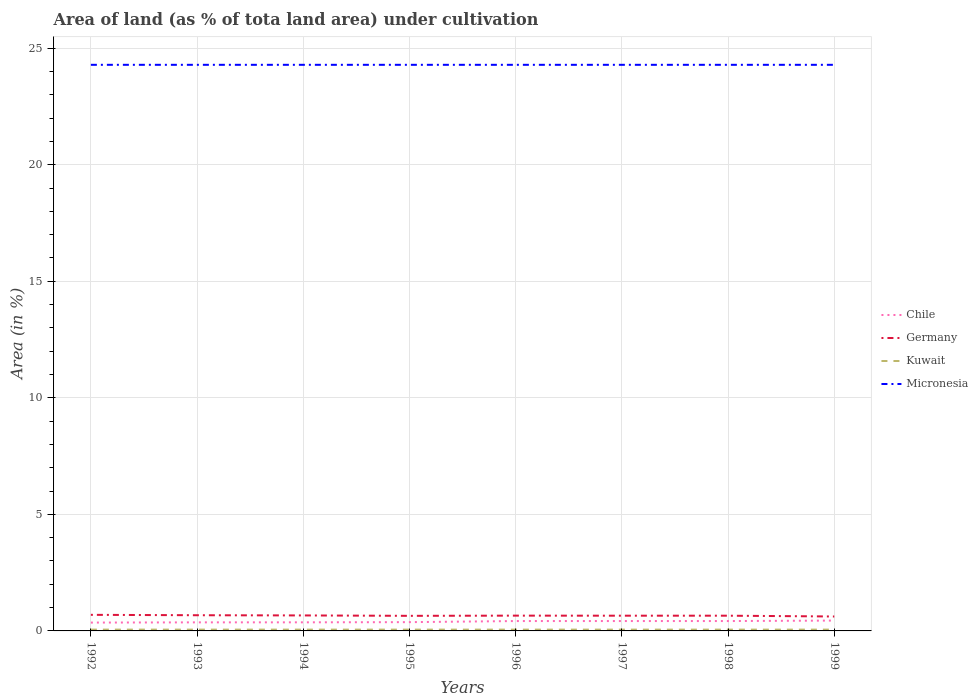How many different coloured lines are there?
Your answer should be very brief. 4. Is the number of lines equal to the number of legend labels?
Keep it short and to the point. Yes. Across all years, what is the maximum percentage of land under cultivation in Kuwait?
Give a very brief answer. 0.06. What is the total percentage of land under cultivation in Kuwait in the graph?
Provide a short and direct response. 0. What is the difference between the highest and the second highest percentage of land under cultivation in Micronesia?
Provide a short and direct response. 0. Is the percentage of land under cultivation in Micronesia strictly greater than the percentage of land under cultivation in Germany over the years?
Your response must be concise. No. How many years are there in the graph?
Give a very brief answer. 8. What is the difference between two consecutive major ticks on the Y-axis?
Make the answer very short. 5. Does the graph contain any zero values?
Keep it short and to the point. No. Where does the legend appear in the graph?
Offer a very short reply. Center right. How many legend labels are there?
Ensure brevity in your answer.  4. What is the title of the graph?
Ensure brevity in your answer.  Area of land (as % of tota land area) under cultivation. Does "Iceland" appear as one of the legend labels in the graph?
Give a very brief answer. No. What is the label or title of the X-axis?
Your response must be concise. Years. What is the label or title of the Y-axis?
Your answer should be compact. Area (in %). What is the Area (in %) of Chile in 1992?
Provide a short and direct response. 0.36. What is the Area (in %) of Germany in 1992?
Your answer should be compact. 0.69. What is the Area (in %) of Kuwait in 1992?
Ensure brevity in your answer.  0.06. What is the Area (in %) in Micronesia in 1992?
Your answer should be compact. 24.29. What is the Area (in %) of Chile in 1993?
Provide a short and direct response. 0.37. What is the Area (in %) in Germany in 1993?
Your response must be concise. 0.67. What is the Area (in %) in Kuwait in 1993?
Ensure brevity in your answer.  0.06. What is the Area (in %) in Micronesia in 1993?
Give a very brief answer. 24.29. What is the Area (in %) of Chile in 1994?
Ensure brevity in your answer.  0.37. What is the Area (in %) in Germany in 1994?
Give a very brief answer. 0.66. What is the Area (in %) in Kuwait in 1994?
Your answer should be compact. 0.06. What is the Area (in %) of Micronesia in 1994?
Offer a very short reply. 24.29. What is the Area (in %) in Chile in 1995?
Give a very brief answer. 0.38. What is the Area (in %) of Germany in 1995?
Ensure brevity in your answer.  0.65. What is the Area (in %) in Kuwait in 1995?
Give a very brief answer. 0.06. What is the Area (in %) in Micronesia in 1995?
Make the answer very short. 24.29. What is the Area (in %) in Chile in 1996?
Give a very brief answer. 0.42. What is the Area (in %) in Germany in 1996?
Give a very brief answer. 0.66. What is the Area (in %) of Kuwait in 1996?
Make the answer very short. 0.06. What is the Area (in %) of Micronesia in 1996?
Provide a succinct answer. 24.29. What is the Area (in %) of Chile in 1997?
Your answer should be compact. 0.42. What is the Area (in %) in Germany in 1997?
Ensure brevity in your answer.  0.65. What is the Area (in %) of Kuwait in 1997?
Offer a very short reply. 0.06. What is the Area (in %) of Micronesia in 1997?
Provide a succinct answer. 24.29. What is the Area (in %) in Chile in 1998?
Offer a terse response. 0.42. What is the Area (in %) in Germany in 1998?
Offer a terse response. 0.65. What is the Area (in %) of Kuwait in 1998?
Your answer should be compact. 0.06. What is the Area (in %) in Micronesia in 1998?
Your response must be concise. 24.29. What is the Area (in %) of Chile in 1999?
Make the answer very short. 0.44. What is the Area (in %) in Germany in 1999?
Keep it short and to the point. 0.62. What is the Area (in %) in Kuwait in 1999?
Give a very brief answer. 0.06. What is the Area (in %) of Micronesia in 1999?
Make the answer very short. 24.29. Across all years, what is the maximum Area (in %) of Chile?
Your answer should be compact. 0.44. Across all years, what is the maximum Area (in %) of Germany?
Your response must be concise. 0.69. Across all years, what is the maximum Area (in %) of Kuwait?
Provide a short and direct response. 0.06. Across all years, what is the maximum Area (in %) in Micronesia?
Ensure brevity in your answer.  24.29. Across all years, what is the minimum Area (in %) of Chile?
Offer a very short reply. 0.36. Across all years, what is the minimum Area (in %) in Germany?
Provide a short and direct response. 0.62. Across all years, what is the minimum Area (in %) in Kuwait?
Give a very brief answer. 0.06. Across all years, what is the minimum Area (in %) in Micronesia?
Your answer should be compact. 24.29. What is the total Area (in %) in Chile in the graph?
Your response must be concise. 3.18. What is the total Area (in %) in Germany in the graph?
Your answer should be compact. 5.26. What is the total Area (in %) in Kuwait in the graph?
Offer a very short reply. 0.45. What is the total Area (in %) in Micronesia in the graph?
Make the answer very short. 194.29. What is the difference between the Area (in %) in Chile in 1992 and that in 1993?
Provide a succinct answer. -0.01. What is the difference between the Area (in %) in Germany in 1992 and that in 1993?
Make the answer very short. 0.02. What is the difference between the Area (in %) in Micronesia in 1992 and that in 1993?
Offer a very short reply. 0. What is the difference between the Area (in %) in Chile in 1992 and that in 1994?
Give a very brief answer. -0.01. What is the difference between the Area (in %) of Germany in 1992 and that in 1994?
Your answer should be compact. 0.03. What is the difference between the Area (in %) of Kuwait in 1992 and that in 1994?
Ensure brevity in your answer.  0. What is the difference between the Area (in %) of Micronesia in 1992 and that in 1994?
Provide a succinct answer. 0. What is the difference between the Area (in %) of Chile in 1992 and that in 1995?
Keep it short and to the point. -0.02. What is the difference between the Area (in %) of Germany in 1992 and that in 1995?
Your answer should be compact. 0.04. What is the difference between the Area (in %) of Kuwait in 1992 and that in 1995?
Give a very brief answer. 0. What is the difference between the Area (in %) of Chile in 1992 and that in 1996?
Ensure brevity in your answer.  -0.07. What is the difference between the Area (in %) of Germany in 1992 and that in 1996?
Offer a very short reply. 0.03. What is the difference between the Area (in %) in Kuwait in 1992 and that in 1996?
Provide a short and direct response. 0. What is the difference between the Area (in %) in Chile in 1992 and that in 1997?
Offer a terse response. -0.07. What is the difference between the Area (in %) in Germany in 1992 and that in 1997?
Offer a terse response. 0.04. What is the difference between the Area (in %) of Chile in 1992 and that in 1998?
Your answer should be very brief. -0.07. What is the difference between the Area (in %) of Germany in 1992 and that in 1998?
Make the answer very short. 0.04. What is the difference between the Area (in %) of Kuwait in 1992 and that in 1998?
Keep it short and to the point. 0. What is the difference between the Area (in %) in Micronesia in 1992 and that in 1998?
Your answer should be compact. 0. What is the difference between the Area (in %) in Chile in 1992 and that in 1999?
Offer a very short reply. -0.09. What is the difference between the Area (in %) of Germany in 1992 and that in 1999?
Provide a succinct answer. 0.07. What is the difference between the Area (in %) of Micronesia in 1992 and that in 1999?
Give a very brief answer. 0. What is the difference between the Area (in %) in Chile in 1993 and that in 1994?
Your response must be concise. -0. What is the difference between the Area (in %) in Germany in 1993 and that in 1994?
Your answer should be compact. 0.01. What is the difference between the Area (in %) of Kuwait in 1993 and that in 1994?
Make the answer very short. 0. What is the difference between the Area (in %) of Chile in 1993 and that in 1995?
Provide a short and direct response. -0.01. What is the difference between the Area (in %) in Germany in 1993 and that in 1995?
Your answer should be very brief. 0.03. What is the difference between the Area (in %) of Chile in 1993 and that in 1996?
Keep it short and to the point. -0.06. What is the difference between the Area (in %) of Germany in 1993 and that in 1996?
Provide a short and direct response. 0.02. What is the difference between the Area (in %) in Chile in 1993 and that in 1997?
Make the answer very short. -0.06. What is the difference between the Area (in %) of Germany in 1993 and that in 1997?
Ensure brevity in your answer.  0.02. What is the difference between the Area (in %) of Chile in 1993 and that in 1998?
Keep it short and to the point. -0.06. What is the difference between the Area (in %) of Germany in 1993 and that in 1998?
Give a very brief answer. 0.02. What is the difference between the Area (in %) in Kuwait in 1993 and that in 1998?
Provide a succinct answer. 0. What is the difference between the Area (in %) in Micronesia in 1993 and that in 1998?
Provide a short and direct response. 0. What is the difference between the Area (in %) of Chile in 1993 and that in 1999?
Ensure brevity in your answer.  -0.08. What is the difference between the Area (in %) of Germany in 1993 and that in 1999?
Your answer should be very brief. 0.05. What is the difference between the Area (in %) of Micronesia in 1993 and that in 1999?
Your response must be concise. 0. What is the difference between the Area (in %) of Chile in 1994 and that in 1995?
Your answer should be compact. -0.01. What is the difference between the Area (in %) of Germany in 1994 and that in 1995?
Offer a very short reply. 0.02. What is the difference between the Area (in %) of Kuwait in 1994 and that in 1995?
Keep it short and to the point. 0. What is the difference between the Area (in %) in Micronesia in 1994 and that in 1995?
Offer a terse response. 0. What is the difference between the Area (in %) in Chile in 1994 and that in 1996?
Give a very brief answer. -0.06. What is the difference between the Area (in %) of Germany in 1994 and that in 1996?
Ensure brevity in your answer.  0.01. What is the difference between the Area (in %) of Kuwait in 1994 and that in 1996?
Offer a terse response. 0. What is the difference between the Area (in %) in Chile in 1994 and that in 1997?
Provide a short and direct response. -0.06. What is the difference between the Area (in %) in Germany in 1994 and that in 1997?
Provide a short and direct response. 0.01. What is the difference between the Area (in %) in Kuwait in 1994 and that in 1997?
Offer a terse response. 0. What is the difference between the Area (in %) of Chile in 1994 and that in 1998?
Ensure brevity in your answer.  -0.06. What is the difference between the Area (in %) of Germany in 1994 and that in 1998?
Give a very brief answer. 0.01. What is the difference between the Area (in %) of Micronesia in 1994 and that in 1998?
Make the answer very short. 0. What is the difference between the Area (in %) in Chile in 1994 and that in 1999?
Give a very brief answer. -0.08. What is the difference between the Area (in %) of Germany in 1994 and that in 1999?
Provide a short and direct response. 0.05. What is the difference between the Area (in %) in Micronesia in 1994 and that in 1999?
Your answer should be compact. 0. What is the difference between the Area (in %) in Chile in 1995 and that in 1996?
Provide a short and direct response. -0.05. What is the difference between the Area (in %) in Germany in 1995 and that in 1996?
Provide a short and direct response. -0.01. What is the difference between the Area (in %) of Micronesia in 1995 and that in 1996?
Offer a very short reply. 0. What is the difference between the Area (in %) in Chile in 1995 and that in 1997?
Offer a very short reply. -0.05. What is the difference between the Area (in %) of Germany in 1995 and that in 1997?
Ensure brevity in your answer.  -0.01. What is the difference between the Area (in %) of Micronesia in 1995 and that in 1997?
Offer a terse response. 0. What is the difference between the Area (in %) of Chile in 1995 and that in 1998?
Provide a short and direct response. -0.05. What is the difference between the Area (in %) of Germany in 1995 and that in 1998?
Provide a succinct answer. -0.01. What is the difference between the Area (in %) of Kuwait in 1995 and that in 1998?
Offer a terse response. 0. What is the difference between the Area (in %) of Micronesia in 1995 and that in 1998?
Offer a terse response. 0. What is the difference between the Area (in %) in Chile in 1995 and that in 1999?
Your answer should be compact. -0.07. What is the difference between the Area (in %) in Germany in 1995 and that in 1999?
Keep it short and to the point. 0.03. What is the difference between the Area (in %) in Micronesia in 1995 and that in 1999?
Your response must be concise. 0. What is the difference between the Area (in %) in Chile in 1996 and that in 1997?
Provide a short and direct response. 0. What is the difference between the Area (in %) in Germany in 1996 and that in 1997?
Give a very brief answer. 0. What is the difference between the Area (in %) in Germany in 1996 and that in 1998?
Your answer should be compact. 0. What is the difference between the Area (in %) in Chile in 1996 and that in 1999?
Offer a terse response. -0.02. What is the difference between the Area (in %) of Germany in 1996 and that in 1999?
Keep it short and to the point. 0.04. What is the difference between the Area (in %) of Kuwait in 1996 and that in 1999?
Provide a succinct answer. 0. What is the difference between the Area (in %) of Germany in 1997 and that in 1998?
Provide a succinct answer. -0. What is the difference between the Area (in %) in Chile in 1997 and that in 1999?
Give a very brief answer. -0.02. What is the difference between the Area (in %) in Germany in 1997 and that in 1999?
Provide a succinct answer. 0.03. What is the difference between the Area (in %) in Kuwait in 1997 and that in 1999?
Keep it short and to the point. 0. What is the difference between the Area (in %) in Chile in 1998 and that in 1999?
Provide a succinct answer. -0.02. What is the difference between the Area (in %) of Germany in 1998 and that in 1999?
Make the answer very short. 0.03. What is the difference between the Area (in %) in Micronesia in 1998 and that in 1999?
Your answer should be compact. 0. What is the difference between the Area (in %) of Chile in 1992 and the Area (in %) of Germany in 1993?
Offer a very short reply. -0.32. What is the difference between the Area (in %) in Chile in 1992 and the Area (in %) in Kuwait in 1993?
Offer a terse response. 0.3. What is the difference between the Area (in %) in Chile in 1992 and the Area (in %) in Micronesia in 1993?
Keep it short and to the point. -23.93. What is the difference between the Area (in %) of Germany in 1992 and the Area (in %) of Kuwait in 1993?
Your response must be concise. 0.63. What is the difference between the Area (in %) in Germany in 1992 and the Area (in %) in Micronesia in 1993?
Keep it short and to the point. -23.6. What is the difference between the Area (in %) of Kuwait in 1992 and the Area (in %) of Micronesia in 1993?
Offer a terse response. -24.23. What is the difference between the Area (in %) of Chile in 1992 and the Area (in %) of Germany in 1994?
Offer a very short reply. -0.31. What is the difference between the Area (in %) of Chile in 1992 and the Area (in %) of Kuwait in 1994?
Ensure brevity in your answer.  0.3. What is the difference between the Area (in %) of Chile in 1992 and the Area (in %) of Micronesia in 1994?
Your response must be concise. -23.93. What is the difference between the Area (in %) of Germany in 1992 and the Area (in %) of Kuwait in 1994?
Your answer should be very brief. 0.63. What is the difference between the Area (in %) in Germany in 1992 and the Area (in %) in Micronesia in 1994?
Your answer should be very brief. -23.6. What is the difference between the Area (in %) in Kuwait in 1992 and the Area (in %) in Micronesia in 1994?
Keep it short and to the point. -24.23. What is the difference between the Area (in %) of Chile in 1992 and the Area (in %) of Germany in 1995?
Ensure brevity in your answer.  -0.29. What is the difference between the Area (in %) of Chile in 1992 and the Area (in %) of Kuwait in 1995?
Your answer should be compact. 0.3. What is the difference between the Area (in %) in Chile in 1992 and the Area (in %) in Micronesia in 1995?
Give a very brief answer. -23.93. What is the difference between the Area (in %) of Germany in 1992 and the Area (in %) of Kuwait in 1995?
Make the answer very short. 0.63. What is the difference between the Area (in %) of Germany in 1992 and the Area (in %) of Micronesia in 1995?
Keep it short and to the point. -23.6. What is the difference between the Area (in %) in Kuwait in 1992 and the Area (in %) in Micronesia in 1995?
Keep it short and to the point. -24.23. What is the difference between the Area (in %) of Chile in 1992 and the Area (in %) of Germany in 1996?
Provide a short and direct response. -0.3. What is the difference between the Area (in %) of Chile in 1992 and the Area (in %) of Kuwait in 1996?
Your answer should be very brief. 0.3. What is the difference between the Area (in %) of Chile in 1992 and the Area (in %) of Micronesia in 1996?
Your answer should be compact. -23.93. What is the difference between the Area (in %) in Germany in 1992 and the Area (in %) in Kuwait in 1996?
Give a very brief answer. 0.63. What is the difference between the Area (in %) in Germany in 1992 and the Area (in %) in Micronesia in 1996?
Give a very brief answer. -23.6. What is the difference between the Area (in %) in Kuwait in 1992 and the Area (in %) in Micronesia in 1996?
Your answer should be very brief. -24.23. What is the difference between the Area (in %) of Chile in 1992 and the Area (in %) of Germany in 1997?
Your answer should be compact. -0.3. What is the difference between the Area (in %) in Chile in 1992 and the Area (in %) in Kuwait in 1997?
Your answer should be compact. 0.3. What is the difference between the Area (in %) in Chile in 1992 and the Area (in %) in Micronesia in 1997?
Your response must be concise. -23.93. What is the difference between the Area (in %) in Germany in 1992 and the Area (in %) in Kuwait in 1997?
Your response must be concise. 0.63. What is the difference between the Area (in %) in Germany in 1992 and the Area (in %) in Micronesia in 1997?
Ensure brevity in your answer.  -23.6. What is the difference between the Area (in %) in Kuwait in 1992 and the Area (in %) in Micronesia in 1997?
Offer a very short reply. -24.23. What is the difference between the Area (in %) of Chile in 1992 and the Area (in %) of Germany in 1998?
Provide a succinct answer. -0.3. What is the difference between the Area (in %) of Chile in 1992 and the Area (in %) of Kuwait in 1998?
Your answer should be compact. 0.3. What is the difference between the Area (in %) of Chile in 1992 and the Area (in %) of Micronesia in 1998?
Provide a succinct answer. -23.93. What is the difference between the Area (in %) of Germany in 1992 and the Area (in %) of Kuwait in 1998?
Offer a terse response. 0.63. What is the difference between the Area (in %) in Germany in 1992 and the Area (in %) in Micronesia in 1998?
Offer a very short reply. -23.6. What is the difference between the Area (in %) of Kuwait in 1992 and the Area (in %) of Micronesia in 1998?
Provide a short and direct response. -24.23. What is the difference between the Area (in %) of Chile in 1992 and the Area (in %) of Germany in 1999?
Offer a terse response. -0.26. What is the difference between the Area (in %) in Chile in 1992 and the Area (in %) in Kuwait in 1999?
Provide a short and direct response. 0.3. What is the difference between the Area (in %) of Chile in 1992 and the Area (in %) of Micronesia in 1999?
Give a very brief answer. -23.93. What is the difference between the Area (in %) of Germany in 1992 and the Area (in %) of Kuwait in 1999?
Offer a very short reply. 0.63. What is the difference between the Area (in %) in Germany in 1992 and the Area (in %) in Micronesia in 1999?
Your answer should be very brief. -23.6. What is the difference between the Area (in %) in Kuwait in 1992 and the Area (in %) in Micronesia in 1999?
Your answer should be compact. -24.23. What is the difference between the Area (in %) of Chile in 1993 and the Area (in %) of Germany in 1994?
Your answer should be compact. -0.3. What is the difference between the Area (in %) of Chile in 1993 and the Area (in %) of Kuwait in 1994?
Offer a very short reply. 0.31. What is the difference between the Area (in %) in Chile in 1993 and the Area (in %) in Micronesia in 1994?
Ensure brevity in your answer.  -23.92. What is the difference between the Area (in %) of Germany in 1993 and the Area (in %) of Kuwait in 1994?
Your response must be concise. 0.62. What is the difference between the Area (in %) in Germany in 1993 and the Area (in %) in Micronesia in 1994?
Offer a terse response. -23.61. What is the difference between the Area (in %) of Kuwait in 1993 and the Area (in %) of Micronesia in 1994?
Your answer should be very brief. -24.23. What is the difference between the Area (in %) of Chile in 1993 and the Area (in %) of Germany in 1995?
Offer a very short reply. -0.28. What is the difference between the Area (in %) in Chile in 1993 and the Area (in %) in Kuwait in 1995?
Your answer should be compact. 0.31. What is the difference between the Area (in %) of Chile in 1993 and the Area (in %) of Micronesia in 1995?
Ensure brevity in your answer.  -23.92. What is the difference between the Area (in %) of Germany in 1993 and the Area (in %) of Kuwait in 1995?
Keep it short and to the point. 0.62. What is the difference between the Area (in %) of Germany in 1993 and the Area (in %) of Micronesia in 1995?
Keep it short and to the point. -23.61. What is the difference between the Area (in %) of Kuwait in 1993 and the Area (in %) of Micronesia in 1995?
Provide a succinct answer. -24.23. What is the difference between the Area (in %) in Chile in 1993 and the Area (in %) in Germany in 1996?
Provide a short and direct response. -0.29. What is the difference between the Area (in %) in Chile in 1993 and the Area (in %) in Kuwait in 1996?
Your response must be concise. 0.31. What is the difference between the Area (in %) in Chile in 1993 and the Area (in %) in Micronesia in 1996?
Give a very brief answer. -23.92. What is the difference between the Area (in %) in Germany in 1993 and the Area (in %) in Kuwait in 1996?
Your answer should be compact. 0.62. What is the difference between the Area (in %) of Germany in 1993 and the Area (in %) of Micronesia in 1996?
Your answer should be compact. -23.61. What is the difference between the Area (in %) of Kuwait in 1993 and the Area (in %) of Micronesia in 1996?
Provide a short and direct response. -24.23. What is the difference between the Area (in %) of Chile in 1993 and the Area (in %) of Germany in 1997?
Make the answer very short. -0.29. What is the difference between the Area (in %) in Chile in 1993 and the Area (in %) in Kuwait in 1997?
Make the answer very short. 0.31. What is the difference between the Area (in %) of Chile in 1993 and the Area (in %) of Micronesia in 1997?
Make the answer very short. -23.92. What is the difference between the Area (in %) of Germany in 1993 and the Area (in %) of Kuwait in 1997?
Your answer should be compact. 0.62. What is the difference between the Area (in %) of Germany in 1993 and the Area (in %) of Micronesia in 1997?
Your answer should be very brief. -23.61. What is the difference between the Area (in %) in Kuwait in 1993 and the Area (in %) in Micronesia in 1997?
Provide a succinct answer. -24.23. What is the difference between the Area (in %) of Chile in 1993 and the Area (in %) of Germany in 1998?
Keep it short and to the point. -0.29. What is the difference between the Area (in %) in Chile in 1993 and the Area (in %) in Kuwait in 1998?
Provide a succinct answer. 0.31. What is the difference between the Area (in %) of Chile in 1993 and the Area (in %) of Micronesia in 1998?
Keep it short and to the point. -23.92. What is the difference between the Area (in %) in Germany in 1993 and the Area (in %) in Kuwait in 1998?
Provide a succinct answer. 0.62. What is the difference between the Area (in %) of Germany in 1993 and the Area (in %) of Micronesia in 1998?
Keep it short and to the point. -23.61. What is the difference between the Area (in %) of Kuwait in 1993 and the Area (in %) of Micronesia in 1998?
Offer a terse response. -24.23. What is the difference between the Area (in %) in Chile in 1993 and the Area (in %) in Germany in 1999?
Provide a succinct answer. -0.25. What is the difference between the Area (in %) in Chile in 1993 and the Area (in %) in Kuwait in 1999?
Provide a short and direct response. 0.31. What is the difference between the Area (in %) of Chile in 1993 and the Area (in %) of Micronesia in 1999?
Give a very brief answer. -23.92. What is the difference between the Area (in %) in Germany in 1993 and the Area (in %) in Kuwait in 1999?
Your response must be concise. 0.62. What is the difference between the Area (in %) of Germany in 1993 and the Area (in %) of Micronesia in 1999?
Ensure brevity in your answer.  -23.61. What is the difference between the Area (in %) of Kuwait in 1993 and the Area (in %) of Micronesia in 1999?
Offer a terse response. -24.23. What is the difference between the Area (in %) of Chile in 1994 and the Area (in %) of Germany in 1995?
Ensure brevity in your answer.  -0.28. What is the difference between the Area (in %) in Chile in 1994 and the Area (in %) in Kuwait in 1995?
Make the answer very short. 0.31. What is the difference between the Area (in %) in Chile in 1994 and the Area (in %) in Micronesia in 1995?
Provide a succinct answer. -23.92. What is the difference between the Area (in %) of Germany in 1994 and the Area (in %) of Kuwait in 1995?
Your answer should be very brief. 0.61. What is the difference between the Area (in %) of Germany in 1994 and the Area (in %) of Micronesia in 1995?
Make the answer very short. -23.62. What is the difference between the Area (in %) in Kuwait in 1994 and the Area (in %) in Micronesia in 1995?
Offer a terse response. -24.23. What is the difference between the Area (in %) in Chile in 1994 and the Area (in %) in Germany in 1996?
Provide a short and direct response. -0.29. What is the difference between the Area (in %) of Chile in 1994 and the Area (in %) of Kuwait in 1996?
Your answer should be compact. 0.31. What is the difference between the Area (in %) in Chile in 1994 and the Area (in %) in Micronesia in 1996?
Offer a terse response. -23.92. What is the difference between the Area (in %) in Germany in 1994 and the Area (in %) in Kuwait in 1996?
Your answer should be very brief. 0.61. What is the difference between the Area (in %) in Germany in 1994 and the Area (in %) in Micronesia in 1996?
Keep it short and to the point. -23.62. What is the difference between the Area (in %) of Kuwait in 1994 and the Area (in %) of Micronesia in 1996?
Make the answer very short. -24.23. What is the difference between the Area (in %) in Chile in 1994 and the Area (in %) in Germany in 1997?
Your response must be concise. -0.28. What is the difference between the Area (in %) in Chile in 1994 and the Area (in %) in Kuwait in 1997?
Your answer should be very brief. 0.31. What is the difference between the Area (in %) of Chile in 1994 and the Area (in %) of Micronesia in 1997?
Offer a terse response. -23.92. What is the difference between the Area (in %) of Germany in 1994 and the Area (in %) of Kuwait in 1997?
Your response must be concise. 0.61. What is the difference between the Area (in %) in Germany in 1994 and the Area (in %) in Micronesia in 1997?
Provide a short and direct response. -23.62. What is the difference between the Area (in %) in Kuwait in 1994 and the Area (in %) in Micronesia in 1997?
Provide a short and direct response. -24.23. What is the difference between the Area (in %) of Chile in 1994 and the Area (in %) of Germany in 1998?
Offer a terse response. -0.28. What is the difference between the Area (in %) in Chile in 1994 and the Area (in %) in Kuwait in 1998?
Keep it short and to the point. 0.31. What is the difference between the Area (in %) in Chile in 1994 and the Area (in %) in Micronesia in 1998?
Offer a terse response. -23.92. What is the difference between the Area (in %) in Germany in 1994 and the Area (in %) in Kuwait in 1998?
Make the answer very short. 0.61. What is the difference between the Area (in %) of Germany in 1994 and the Area (in %) of Micronesia in 1998?
Keep it short and to the point. -23.62. What is the difference between the Area (in %) of Kuwait in 1994 and the Area (in %) of Micronesia in 1998?
Your response must be concise. -24.23. What is the difference between the Area (in %) of Chile in 1994 and the Area (in %) of Germany in 1999?
Your answer should be compact. -0.25. What is the difference between the Area (in %) of Chile in 1994 and the Area (in %) of Kuwait in 1999?
Your answer should be compact. 0.31. What is the difference between the Area (in %) of Chile in 1994 and the Area (in %) of Micronesia in 1999?
Provide a short and direct response. -23.92. What is the difference between the Area (in %) of Germany in 1994 and the Area (in %) of Kuwait in 1999?
Provide a succinct answer. 0.61. What is the difference between the Area (in %) of Germany in 1994 and the Area (in %) of Micronesia in 1999?
Your answer should be compact. -23.62. What is the difference between the Area (in %) of Kuwait in 1994 and the Area (in %) of Micronesia in 1999?
Your answer should be compact. -24.23. What is the difference between the Area (in %) of Chile in 1995 and the Area (in %) of Germany in 1996?
Your answer should be very brief. -0.28. What is the difference between the Area (in %) of Chile in 1995 and the Area (in %) of Kuwait in 1996?
Keep it short and to the point. 0.32. What is the difference between the Area (in %) of Chile in 1995 and the Area (in %) of Micronesia in 1996?
Keep it short and to the point. -23.91. What is the difference between the Area (in %) of Germany in 1995 and the Area (in %) of Kuwait in 1996?
Your answer should be compact. 0.59. What is the difference between the Area (in %) in Germany in 1995 and the Area (in %) in Micronesia in 1996?
Provide a succinct answer. -23.64. What is the difference between the Area (in %) in Kuwait in 1995 and the Area (in %) in Micronesia in 1996?
Provide a succinct answer. -24.23. What is the difference between the Area (in %) of Chile in 1995 and the Area (in %) of Germany in 1997?
Your answer should be compact. -0.28. What is the difference between the Area (in %) of Chile in 1995 and the Area (in %) of Kuwait in 1997?
Your response must be concise. 0.32. What is the difference between the Area (in %) of Chile in 1995 and the Area (in %) of Micronesia in 1997?
Offer a very short reply. -23.91. What is the difference between the Area (in %) of Germany in 1995 and the Area (in %) of Kuwait in 1997?
Offer a very short reply. 0.59. What is the difference between the Area (in %) of Germany in 1995 and the Area (in %) of Micronesia in 1997?
Your response must be concise. -23.64. What is the difference between the Area (in %) of Kuwait in 1995 and the Area (in %) of Micronesia in 1997?
Offer a very short reply. -24.23. What is the difference between the Area (in %) of Chile in 1995 and the Area (in %) of Germany in 1998?
Your answer should be very brief. -0.28. What is the difference between the Area (in %) of Chile in 1995 and the Area (in %) of Kuwait in 1998?
Your answer should be compact. 0.32. What is the difference between the Area (in %) of Chile in 1995 and the Area (in %) of Micronesia in 1998?
Offer a very short reply. -23.91. What is the difference between the Area (in %) of Germany in 1995 and the Area (in %) of Kuwait in 1998?
Your response must be concise. 0.59. What is the difference between the Area (in %) of Germany in 1995 and the Area (in %) of Micronesia in 1998?
Keep it short and to the point. -23.64. What is the difference between the Area (in %) in Kuwait in 1995 and the Area (in %) in Micronesia in 1998?
Make the answer very short. -24.23. What is the difference between the Area (in %) in Chile in 1995 and the Area (in %) in Germany in 1999?
Provide a succinct answer. -0.24. What is the difference between the Area (in %) in Chile in 1995 and the Area (in %) in Kuwait in 1999?
Offer a terse response. 0.32. What is the difference between the Area (in %) of Chile in 1995 and the Area (in %) of Micronesia in 1999?
Your response must be concise. -23.91. What is the difference between the Area (in %) in Germany in 1995 and the Area (in %) in Kuwait in 1999?
Ensure brevity in your answer.  0.59. What is the difference between the Area (in %) in Germany in 1995 and the Area (in %) in Micronesia in 1999?
Provide a short and direct response. -23.64. What is the difference between the Area (in %) in Kuwait in 1995 and the Area (in %) in Micronesia in 1999?
Offer a terse response. -24.23. What is the difference between the Area (in %) in Chile in 1996 and the Area (in %) in Germany in 1997?
Provide a short and direct response. -0.23. What is the difference between the Area (in %) of Chile in 1996 and the Area (in %) of Kuwait in 1997?
Your response must be concise. 0.37. What is the difference between the Area (in %) of Chile in 1996 and the Area (in %) of Micronesia in 1997?
Offer a terse response. -23.86. What is the difference between the Area (in %) of Germany in 1996 and the Area (in %) of Kuwait in 1997?
Keep it short and to the point. 0.6. What is the difference between the Area (in %) in Germany in 1996 and the Area (in %) in Micronesia in 1997?
Provide a succinct answer. -23.63. What is the difference between the Area (in %) in Kuwait in 1996 and the Area (in %) in Micronesia in 1997?
Offer a terse response. -24.23. What is the difference between the Area (in %) in Chile in 1996 and the Area (in %) in Germany in 1998?
Keep it short and to the point. -0.23. What is the difference between the Area (in %) of Chile in 1996 and the Area (in %) of Kuwait in 1998?
Your answer should be compact. 0.37. What is the difference between the Area (in %) of Chile in 1996 and the Area (in %) of Micronesia in 1998?
Give a very brief answer. -23.86. What is the difference between the Area (in %) of Germany in 1996 and the Area (in %) of Kuwait in 1998?
Your answer should be very brief. 0.6. What is the difference between the Area (in %) of Germany in 1996 and the Area (in %) of Micronesia in 1998?
Provide a succinct answer. -23.63. What is the difference between the Area (in %) in Kuwait in 1996 and the Area (in %) in Micronesia in 1998?
Your answer should be compact. -24.23. What is the difference between the Area (in %) of Chile in 1996 and the Area (in %) of Germany in 1999?
Keep it short and to the point. -0.2. What is the difference between the Area (in %) in Chile in 1996 and the Area (in %) in Kuwait in 1999?
Keep it short and to the point. 0.37. What is the difference between the Area (in %) in Chile in 1996 and the Area (in %) in Micronesia in 1999?
Ensure brevity in your answer.  -23.86. What is the difference between the Area (in %) in Germany in 1996 and the Area (in %) in Kuwait in 1999?
Your answer should be very brief. 0.6. What is the difference between the Area (in %) in Germany in 1996 and the Area (in %) in Micronesia in 1999?
Offer a terse response. -23.63. What is the difference between the Area (in %) of Kuwait in 1996 and the Area (in %) of Micronesia in 1999?
Your answer should be compact. -24.23. What is the difference between the Area (in %) in Chile in 1997 and the Area (in %) in Germany in 1998?
Provide a short and direct response. -0.23. What is the difference between the Area (in %) in Chile in 1997 and the Area (in %) in Kuwait in 1998?
Give a very brief answer. 0.37. What is the difference between the Area (in %) in Chile in 1997 and the Area (in %) in Micronesia in 1998?
Your answer should be compact. -23.86. What is the difference between the Area (in %) of Germany in 1997 and the Area (in %) of Kuwait in 1998?
Offer a terse response. 0.6. What is the difference between the Area (in %) in Germany in 1997 and the Area (in %) in Micronesia in 1998?
Offer a very short reply. -23.63. What is the difference between the Area (in %) in Kuwait in 1997 and the Area (in %) in Micronesia in 1998?
Your answer should be compact. -24.23. What is the difference between the Area (in %) of Chile in 1997 and the Area (in %) of Germany in 1999?
Your response must be concise. -0.2. What is the difference between the Area (in %) in Chile in 1997 and the Area (in %) in Kuwait in 1999?
Your response must be concise. 0.37. What is the difference between the Area (in %) in Chile in 1997 and the Area (in %) in Micronesia in 1999?
Offer a very short reply. -23.86. What is the difference between the Area (in %) of Germany in 1997 and the Area (in %) of Kuwait in 1999?
Your answer should be very brief. 0.6. What is the difference between the Area (in %) of Germany in 1997 and the Area (in %) of Micronesia in 1999?
Give a very brief answer. -23.63. What is the difference between the Area (in %) of Kuwait in 1997 and the Area (in %) of Micronesia in 1999?
Provide a succinct answer. -24.23. What is the difference between the Area (in %) of Chile in 1998 and the Area (in %) of Germany in 1999?
Offer a terse response. -0.2. What is the difference between the Area (in %) of Chile in 1998 and the Area (in %) of Kuwait in 1999?
Make the answer very short. 0.37. What is the difference between the Area (in %) in Chile in 1998 and the Area (in %) in Micronesia in 1999?
Offer a terse response. -23.86. What is the difference between the Area (in %) of Germany in 1998 and the Area (in %) of Kuwait in 1999?
Keep it short and to the point. 0.6. What is the difference between the Area (in %) in Germany in 1998 and the Area (in %) in Micronesia in 1999?
Give a very brief answer. -23.63. What is the difference between the Area (in %) in Kuwait in 1998 and the Area (in %) in Micronesia in 1999?
Ensure brevity in your answer.  -24.23. What is the average Area (in %) in Chile per year?
Ensure brevity in your answer.  0.4. What is the average Area (in %) in Germany per year?
Your answer should be very brief. 0.66. What is the average Area (in %) of Kuwait per year?
Provide a short and direct response. 0.06. What is the average Area (in %) in Micronesia per year?
Ensure brevity in your answer.  24.29. In the year 1992, what is the difference between the Area (in %) of Chile and Area (in %) of Germany?
Your answer should be very brief. -0.33. In the year 1992, what is the difference between the Area (in %) in Chile and Area (in %) in Kuwait?
Make the answer very short. 0.3. In the year 1992, what is the difference between the Area (in %) of Chile and Area (in %) of Micronesia?
Offer a very short reply. -23.93. In the year 1992, what is the difference between the Area (in %) in Germany and Area (in %) in Kuwait?
Offer a terse response. 0.63. In the year 1992, what is the difference between the Area (in %) of Germany and Area (in %) of Micronesia?
Provide a succinct answer. -23.6. In the year 1992, what is the difference between the Area (in %) in Kuwait and Area (in %) in Micronesia?
Your response must be concise. -24.23. In the year 1993, what is the difference between the Area (in %) in Chile and Area (in %) in Germany?
Make the answer very short. -0.31. In the year 1993, what is the difference between the Area (in %) of Chile and Area (in %) of Kuwait?
Your response must be concise. 0.31. In the year 1993, what is the difference between the Area (in %) in Chile and Area (in %) in Micronesia?
Your response must be concise. -23.92. In the year 1993, what is the difference between the Area (in %) of Germany and Area (in %) of Kuwait?
Your answer should be compact. 0.62. In the year 1993, what is the difference between the Area (in %) in Germany and Area (in %) in Micronesia?
Offer a terse response. -23.61. In the year 1993, what is the difference between the Area (in %) of Kuwait and Area (in %) of Micronesia?
Give a very brief answer. -24.23. In the year 1994, what is the difference between the Area (in %) in Chile and Area (in %) in Germany?
Give a very brief answer. -0.3. In the year 1994, what is the difference between the Area (in %) of Chile and Area (in %) of Kuwait?
Make the answer very short. 0.31. In the year 1994, what is the difference between the Area (in %) of Chile and Area (in %) of Micronesia?
Keep it short and to the point. -23.92. In the year 1994, what is the difference between the Area (in %) of Germany and Area (in %) of Kuwait?
Keep it short and to the point. 0.61. In the year 1994, what is the difference between the Area (in %) of Germany and Area (in %) of Micronesia?
Your answer should be very brief. -23.62. In the year 1994, what is the difference between the Area (in %) in Kuwait and Area (in %) in Micronesia?
Offer a terse response. -24.23. In the year 1995, what is the difference between the Area (in %) of Chile and Area (in %) of Germany?
Your response must be concise. -0.27. In the year 1995, what is the difference between the Area (in %) in Chile and Area (in %) in Kuwait?
Ensure brevity in your answer.  0.32. In the year 1995, what is the difference between the Area (in %) of Chile and Area (in %) of Micronesia?
Give a very brief answer. -23.91. In the year 1995, what is the difference between the Area (in %) of Germany and Area (in %) of Kuwait?
Keep it short and to the point. 0.59. In the year 1995, what is the difference between the Area (in %) of Germany and Area (in %) of Micronesia?
Offer a terse response. -23.64. In the year 1995, what is the difference between the Area (in %) in Kuwait and Area (in %) in Micronesia?
Your response must be concise. -24.23. In the year 1996, what is the difference between the Area (in %) in Chile and Area (in %) in Germany?
Your response must be concise. -0.23. In the year 1996, what is the difference between the Area (in %) of Chile and Area (in %) of Kuwait?
Provide a short and direct response. 0.37. In the year 1996, what is the difference between the Area (in %) of Chile and Area (in %) of Micronesia?
Provide a short and direct response. -23.86. In the year 1996, what is the difference between the Area (in %) of Germany and Area (in %) of Kuwait?
Provide a short and direct response. 0.6. In the year 1996, what is the difference between the Area (in %) in Germany and Area (in %) in Micronesia?
Make the answer very short. -23.63. In the year 1996, what is the difference between the Area (in %) of Kuwait and Area (in %) of Micronesia?
Your response must be concise. -24.23. In the year 1997, what is the difference between the Area (in %) in Chile and Area (in %) in Germany?
Provide a succinct answer. -0.23. In the year 1997, what is the difference between the Area (in %) in Chile and Area (in %) in Kuwait?
Provide a short and direct response. 0.37. In the year 1997, what is the difference between the Area (in %) of Chile and Area (in %) of Micronesia?
Ensure brevity in your answer.  -23.86. In the year 1997, what is the difference between the Area (in %) in Germany and Area (in %) in Kuwait?
Your answer should be compact. 0.6. In the year 1997, what is the difference between the Area (in %) of Germany and Area (in %) of Micronesia?
Offer a terse response. -23.63. In the year 1997, what is the difference between the Area (in %) of Kuwait and Area (in %) of Micronesia?
Your answer should be very brief. -24.23. In the year 1998, what is the difference between the Area (in %) in Chile and Area (in %) in Germany?
Offer a very short reply. -0.23. In the year 1998, what is the difference between the Area (in %) of Chile and Area (in %) of Kuwait?
Offer a terse response. 0.37. In the year 1998, what is the difference between the Area (in %) in Chile and Area (in %) in Micronesia?
Provide a short and direct response. -23.86. In the year 1998, what is the difference between the Area (in %) of Germany and Area (in %) of Kuwait?
Offer a very short reply. 0.6. In the year 1998, what is the difference between the Area (in %) of Germany and Area (in %) of Micronesia?
Your answer should be compact. -23.63. In the year 1998, what is the difference between the Area (in %) of Kuwait and Area (in %) of Micronesia?
Keep it short and to the point. -24.23. In the year 1999, what is the difference between the Area (in %) in Chile and Area (in %) in Germany?
Your answer should be compact. -0.18. In the year 1999, what is the difference between the Area (in %) in Chile and Area (in %) in Kuwait?
Provide a succinct answer. 0.39. In the year 1999, what is the difference between the Area (in %) of Chile and Area (in %) of Micronesia?
Give a very brief answer. -23.84. In the year 1999, what is the difference between the Area (in %) in Germany and Area (in %) in Kuwait?
Offer a terse response. 0.56. In the year 1999, what is the difference between the Area (in %) of Germany and Area (in %) of Micronesia?
Provide a short and direct response. -23.67. In the year 1999, what is the difference between the Area (in %) of Kuwait and Area (in %) of Micronesia?
Offer a terse response. -24.23. What is the ratio of the Area (in %) of Chile in 1992 to that in 1993?
Your response must be concise. 0.97. What is the ratio of the Area (in %) in Germany in 1992 to that in 1993?
Offer a very short reply. 1.03. What is the ratio of the Area (in %) of Chile in 1992 to that in 1994?
Ensure brevity in your answer.  0.97. What is the ratio of the Area (in %) in Germany in 1992 to that in 1994?
Keep it short and to the point. 1.04. What is the ratio of the Area (in %) in Kuwait in 1992 to that in 1994?
Offer a very short reply. 1. What is the ratio of the Area (in %) in Germany in 1992 to that in 1995?
Provide a succinct answer. 1.07. What is the ratio of the Area (in %) of Chile in 1992 to that in 1996?
Make the answer very short. 0.84. What is the ratio of the Area (in %) in Germany in 1992 to that in 1996?
Offer a terse response. 1.05. What is the ratio of the Area (in %) of Kuwait in 1992 to that in 1996?
Your response must be concise. 1. What is the ratio of the Area (in %) in Micronesia in 1992 to that in 1996?
Offer a terse response. 1. What is the ratio of the Area (in %) in Chile in 1992 to that in 1997?
Keep it short and to the point. 0.84. What is the ratio of the Area (in %) in Germany in 1992 to that in 1997?
Make the answer very short. 1.06. What is the ratio of the Area (in %) of Kuwait in 1992 to that in 1997?
Provide a succinct answer. 1. What is the ratio of the Area (in %) in Micronesia in 1992 to that in 1997?
Provide a short and direct response. 1. What is the ratio of the Area (in %) in Chile in 1992 to that in 1998?
Offer a terse response. 0.84. What is the ratio of the Area (in %) in Germany in 1992 to that in 1998?
Offer a very short reply. 1.06. What is the ratio of the Area (in %) in Kuwait in 1992 to that in 1998?
Give a very brief answer. 1. What is the ratio of the Area (in %) of Chile in 1992 to that in 1999?
Offer a very short reply. 0.81. What is the ratio of the Area (in %) of Germany in 1992 to that in 1999?
Make the answer very short. 1.12. What is the ratio of the Area (in %) of Kuwait in 1992 to that in 1999?
Your answer should be very brief. 1. What is the ratio of the Area (in %) of Micronesia in 1992 to that in 1999?
Offer a very short reply. 1. What is the ratio of the Area (in %) of Germany in 1993 to that in 1994?
Provide a short and direct response. 1.01. What is the ratio of the Area (in %) in Kuwait in 1993 to that in 1994?
Your answer should be compact. 1. What is the ratio of the Area (in %) of Micronesia in 1993 to that in 1994?
Provide a succinct answer. 1. What is the ratio of the Area (in %) in Chile in 1993 to that in 1995?
Your answer should be compact. 0.97. What is the ratio of the Area (in %) in Germany in 1993 to that in 1995?
Offer a very short reply. 1.04. What is the ratio of the Area (in %) of Kuwait in 1993 to that in 1995?
Provide a short and direct response. 1. What is the ratio of the Area (in %) in Chile in 1993 to that in 1996?
Keep it short and to the point. 0.87. What is the ratio of the Area (in %) in Germany in 1993 to that in 1996?
Make the answer very short. 1.03. What is the ratio of the Area (in %) in Chile in 1993 to that in 1997?
Provide a short and direct response. 0.87. What is the ratio of the Area (in %) in Germany in 1993 to that in 1997?
Give a very brief answer. 1.03. What is the ratio of the Area (in %) in Kuwait in 1993 to that in 1997?
Provide a short and direct response. 1. What is the ratio of the Area (in %) in Chile in 1993 to that in 1998?
Provide a short and direct response. 0.87. What is the ratio of the Area (in %) in Germany in 1993 to that in 1998?
Provide a short and direct response. 1.03. What is the ratio of the Area (in %) of Chile in 1993 to that in 1999?
Your answer should be very brief. 0.83. What is the ratio of the Area (in %) in Germany in 1993 to that in 1999?
Offer a terse response. 1.09. What is the ratio of the Area (in %) in Kuwait in 1993 to that in 1999?
Keep it short and to the point. 1. What is the ratio of the Area (in %) of Micronesia in 1993 to that in 1999?
Ensure brevity in your answer.  1. What is the ratio of the Area (in %) of Chile in 1994 to that in 1995?
Provide a succinct answer. 0.98. What is the ratio of the Area (in %) of Germany in 1994 to that in 1995?
Provide a short and direct response. 1.03. What is the ratio of the Area (in %) of Kuwait in 1994 to that in 1995?
Give a very brief answer. 1. What is the ratio of the Area (in %) of Chile in 1994 to that in 1996?
Your response must be concise. 0.87. What is the ratio of the Area (in %) in Micronesia in 1994 to that in 1996?
Your response must be concise. 1. What is the ratio of the Area (in %) in Chile in 1994 to that in 1997?
Keep it short and to the point. 0.87. What is the ratio of the Area (in %) of Germany in 1994 to that in 1997?
Offer a very short reply. 1.02. What is the ratio of the Area (in %) of Chile in 1994 to that in 1998?
Keep it short and to the point. 0.87. What is the ratio of the Area (in %) in Germany in 1994 to that in 1998?
Offer a very short reply. 1.02. What is the ratio of the Area (in %) of Chile in 1994 to that in 1999?
Give a very brief answer. 0.83. What is the ratio of the Area (in %) of Germany in 1994 to that in 1999?
Keep it short and to the point. 1.07. What is the ratio of the Area (in %) in Kuwait in 1994 to that in 1999?
Give a very brief answer. 1. What is the ratio of the Area (in %) of Chile in 1995 to that in 1996?
Make the answer very short. 0.89. What is the ratio of the Area (in %) of Germany in 1995 to that in 1996?
Keep it short and to the point. 0.99. What is the ratio of the Area (in %) in Kuwait in 1995 to that in 1996?
Give a very brief answer. 1. What is the ratio of the Area (in %) of Micronesia in 1995 to that in 1996?
Your answer should be compact. 1. What is the ratio of the Area (in %) in Chile in 1995 to that in 1997?
Provide a short and direct response. 0.89. What is the ratio of the Area (in %) of Germany in 1995 to that in 1997?
Your response must be concise. 0.99. What is the ratio of the Area (in %) of Kuwait in 1995 to that in 1997?
Provide a succinct answer. 1. What is the ratio of the Area (in %) of Micronesia in 1995 to that in 1997?
Offer a very short reply. 1. What is the ratio of the Area (in %) in Germany in 1995 to that in 1998?
Offer a very short reply. 0.99. What is the ratio of the Area (in %) of Micronesia in 1995 to that in 1998?
Your answer should be compact. 1. What is the ratio of the Area (in %) in Chile in 1995 to that in 1999?
Provide a succinct answer. 0.85. What is the ratio of the Area (in %) in Germany in 1995 to that in 1999?
Your response must be concise. 1.05. What is the ratio of the Area (in %) in Kuwait in 1995 to that in 1999?
Provide a succinct answer. 1. What is the ratio of the Area (in %) in Chile in 1996 to that in 1997?
Your answer should be very brief. 1. What is the ratio of the Area (in %) in Germany in 1996 to that in 1997?
Your answer should be very brief. 1. What is the ratio of the Area (in %) in Kuwait in 1996 to that in 1997?
Offer a terse response. 1. What is the ratio of the Area (in %) in Micronesia in 1996 to that in 1997?
Keep it short and to the point. 1. What is the ratio of the Area (in %) of Kuwait in 1996 to that in 1998?
Your response must be concise. 1. What is the ratio of the Area (in %) in Micronesia in 1996 to that in 1998?
Provide a short and direct response. 1. What is the ratio of the Area (in %) in Chile in 1996 to that in 1999?
Your answer should be very brief. 0.95. What is the ratio of the Area (in %) in Germany in 1996 to that in 1999?
Make the answer very short. 1.06. What is the ratio of the Area (in %) of Kuwait in 1996 to that in 1999?
Make the answer very short. 1. What is the ratio of the Area (in %) of Kuwait in 1997 to that in 1998?
Your answer should be very brief. 1. What is the ratio of the Area (in %) of Micronesia in 1997 to that in 1998?
Offer a terse response. 1. What is the ratio of the Area (in %) of Chile in 1997 to that in 1999?
Your answer should be compact. 0.95. What is the ratio of the Area (in %) in Germany in 1997 to that in 1999?
Your response must be concise. 1.06. What is the ratio of the Area (in %) of Chile in 1998 to that in 1999?
Give a very brief answer. 0.95. What is the ratio of the Area (in %) in Germany in 1998 to that in 1999?
Give a very brief answer. 1.06. What is the ratio of the Area (in %) of Kuwait in 1998 to that in 1999?
Provide a short and direct response. 1. What is the difference between the highest and the second highest Area (in %) of Chile?
Your response must be concise. 0.02. What is the difference between the highest and the second highest Area (in %) in Germany?
Provide a short and direct response. 0.02. What is the difference between the highest and the second highest Area (in %) of Kuwait?
Keep it short and to the point. 0. What is the difference between the highest and the lowest Area (in %) of Chile?
Provide a short and direct response. 0.09. What is the difference between the highest and the lowest Area (in %) in Germany?
Offer a very short reply. 0.07. What is the difference between the highest and the lowest Area (in %) in Micronesia?
Ensure brevity in your answer.  0. 